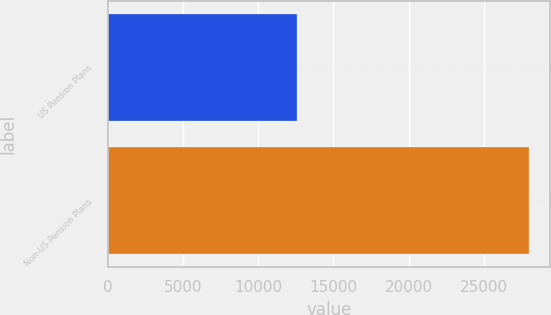Convert chart to OTSL. <chart><loc_0><loc_0><loc_500><loc_500><bar_chart><fcel>US Pension Plans<fcel>Non-US Pension Plans<nl><fcel>12563<fcel>28023<nl></chart> 